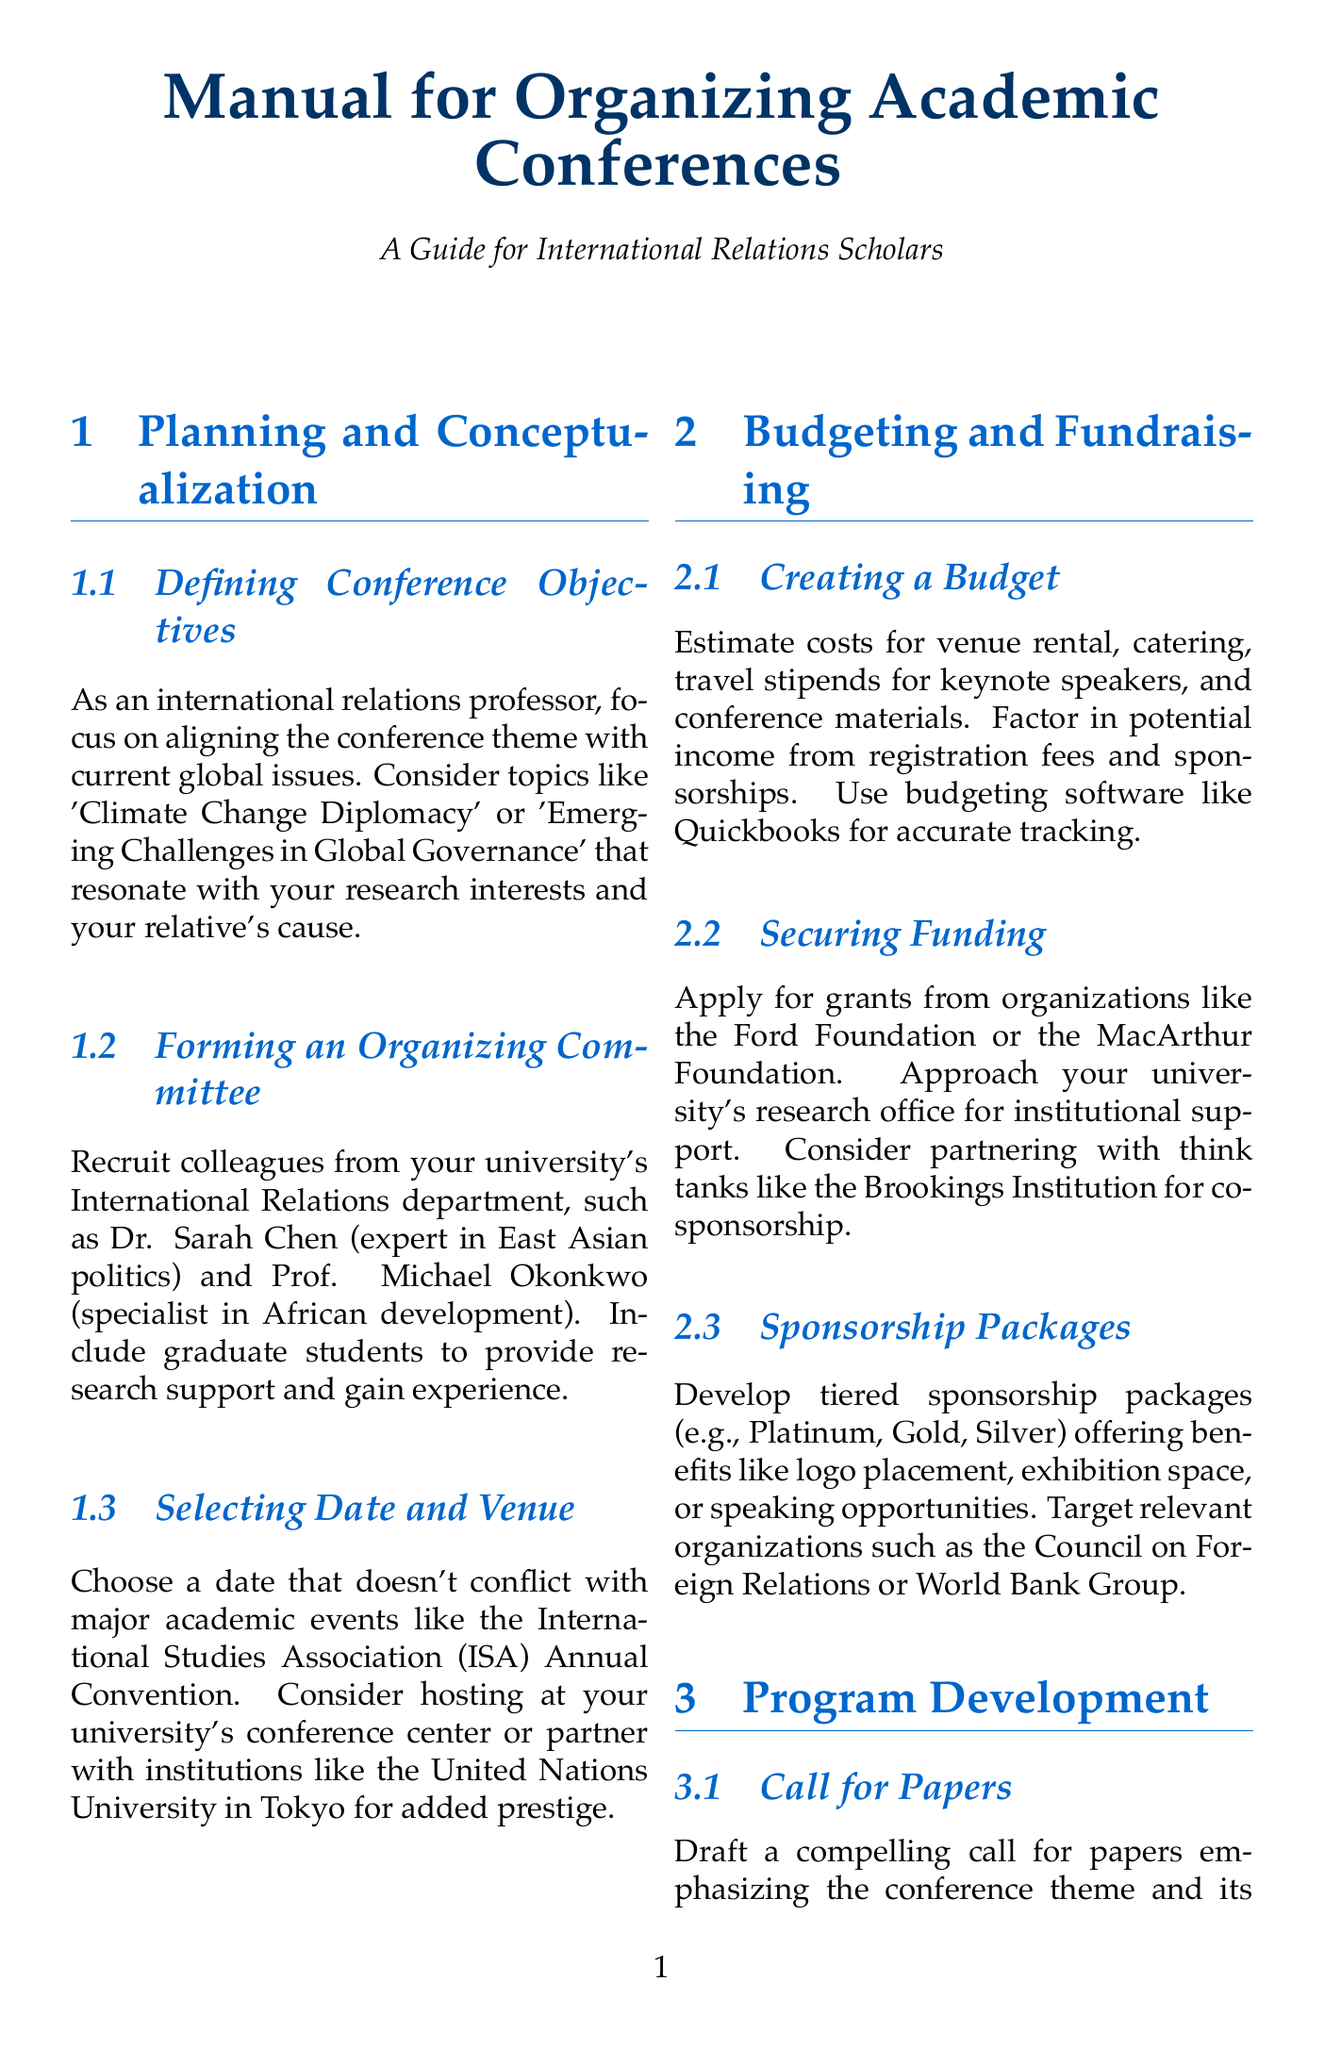What is a potential conference theme? The document suggests themes like 'Climate Change Diplomacy' or 'Emerging Challenges in Global Governance' that resonate with current global issues and personal research interests.
Answer: Climate Change Diplomacy Who is an expert in East Asian politics? The document provides the name of Dr. Sarah Chen as a colleague to recruit for the organizing committee who specializes in East Asian politics.
Answer: Dr. Sarah Chen What software is recommended for budgeting? The document mentions using budgeting software for accurate tracking of expenses, specifically naming Quickbooks as an option.
Answer: Quickbooks What item is included in sponsorship packages? The document lists benefits like logo placement, exhibition space, or speaking opportunities as part of the sponsorship packages.
Answer: Logo placement What position does Dr. Ngozi Okonjo-Iweala hold? The document states that Dr. Ngozi Okonjo-Iweala is the Director-General of the WTO, which enhances her suitability as a keynote speaker.
Answer: Director-General of the WTO What is a tool suggested for gathering feedback? The manual recommends using SurveyMonkey to conduct post-conference surveys and gather attendee feedback on the event.
Answer: SurveyMonkey How many types of post-conference activities are there? The document identifies three distinct activities to engage in after the conference concludes: Publication of Proceedings, Impact Assessment, and Follow-up Networking, indicating a total of three.
Answer: 3 What is a strategy to boost registration participation? The document suggests offering early bird discounts and student rates to encourage diverse participation in conference registrations.
Answer: Early bird discounts What type of events are planned for follow-up networking? The document plans for potential follow-up events or webinars to maintain momentum on key issues discussed during the conference.
Answer: Webinars 